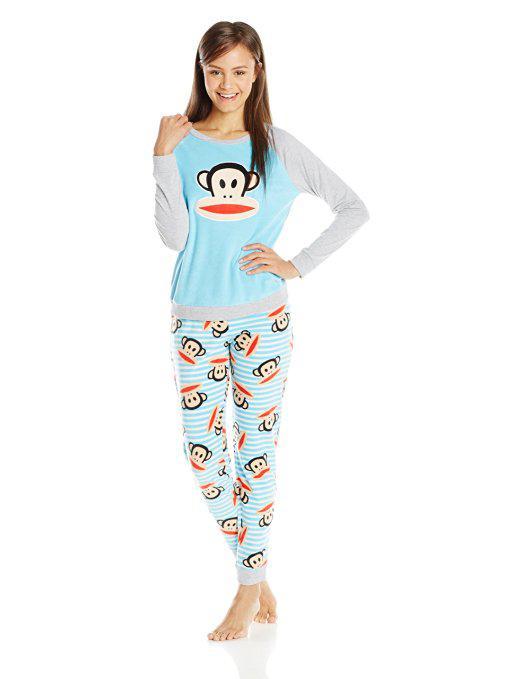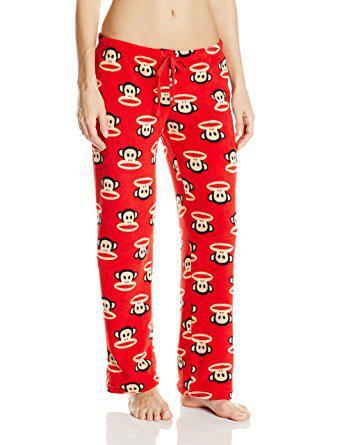The first image is the image on the left, the second image is the image on the right. Analyze the images presented: Is the assertion "Pajama shirts in both images have sleeves the same length." valid? Answer yes or no. No. 